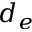Convert formula to latex. <formula><loc_0><loc_0><loc_500><loc_500>d _ { e }</formula> 